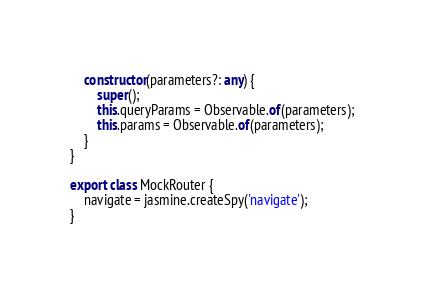Convert code to text. <code><loc_0><loc_0><loc_500><loc_500><_TypeScript_>
    constructor(parameters?: any) {
        super();
        this.queryParams = Observable.of(parameters);
        this.params = Observable.of(parameters);
    }
}

export class MockRouter {
    navigate = jasmine.createSpy('navigate');
}
</code> 